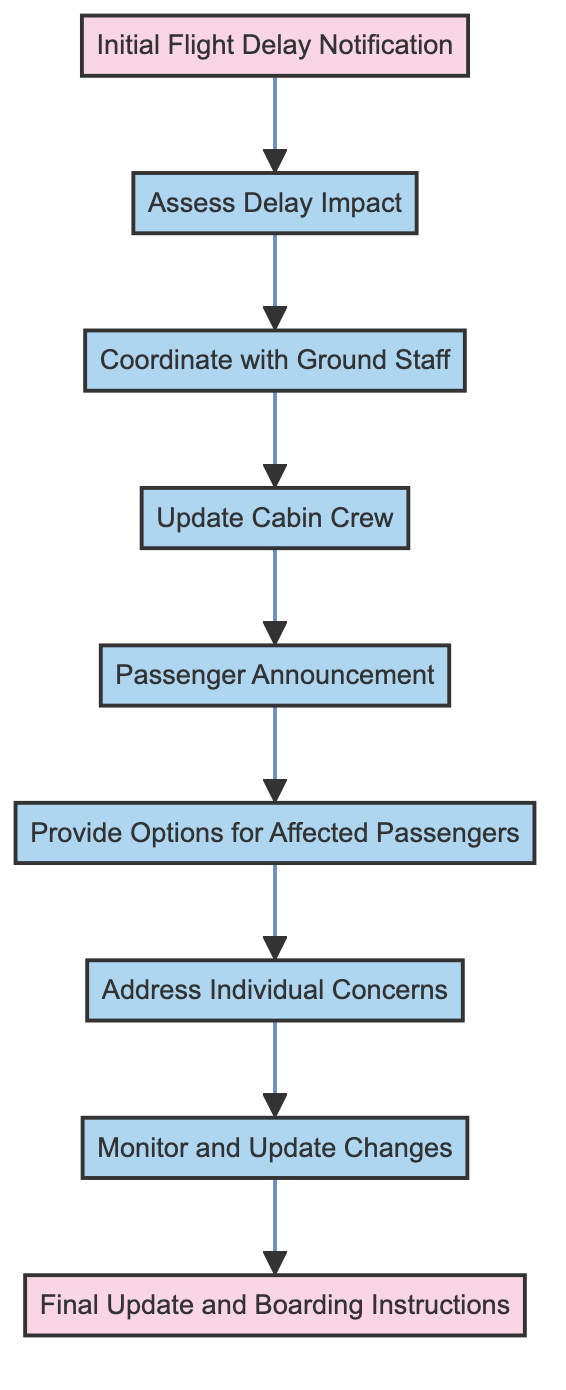What is the first step after an initial flight delay notification? According to the diagram, the first action that takes place after the initial flight delay notification (Node 1) is to assess the delay impact (Node 2).
Answer: Assess Delay Impact How many actions are there in the diagram? By counting the nodes classified as actions, there are a total of 8 actions: Assess Delay Impact, Coordinate with Ground Staff, Update Cabin Crew, Passenger Announcement, Provide Options for Affected Passengers, Address Individual Concerns, Monitor and Update Changes.
Answer: 8 What action follows the 'Passenger Announcement'? After the 'Passenger Announcement' (Node 5), the next action that occurs is 'Provide Options for Affected Passengers' (Node 6).
Answer: Provide Options for Affected Passengers What is the final step in the process? The final step in the process, as indicated in the diagram, is 'Final Update and Boarding Instructions' (Node 9).
Answer: Final Update and Boarding Instructions Which action directly precedes the updating of cabin crew? The action that directly precedes 'Update Cabin Crew' (Node 4) is 'Coordinate with Ground Staff' (Node 3) according to the flow of the diagram.
Answer: Coordinate with Ground Staff What is the relationship between 'Assess Delay Impact' and 'Coordinate with Ground Staff'? 'Assess Delay Impact' (Node 2) is a prerequisite for 'Coordinate with Ground Staff' (Node 3), meaning that assessing the delay impact must happen before coordination with the ground staff can occur.
Answer: Predecessor-Successor Relationship 